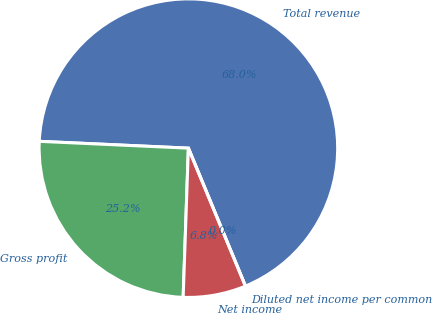Convert chart. <chart><loc_0><loc_0><loc_500><loc_500><pie_chart><fcel>Total revenue<fcel>Gross profit<fcel>Net income<fcel>Diluted net income per common<nl><fcel>68.03%<fcel>25.17%<fcel>6.8%<fcel>0.0%<nl></chart> 